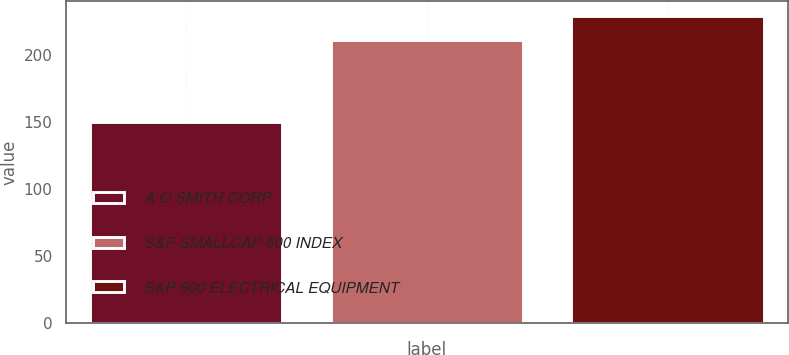<chart> <loc_0><loc_0><loc_500><loc_500><bar_chart><fcel>A O SMITH CORP<fcel>S&P SMALLCAP 600 INDEX<fcel>S&P 600 ELECTRICAL EQUIPMENT<nl><fcel>150.26<fcel>211.01<fcel>228.83<nl></chart> 